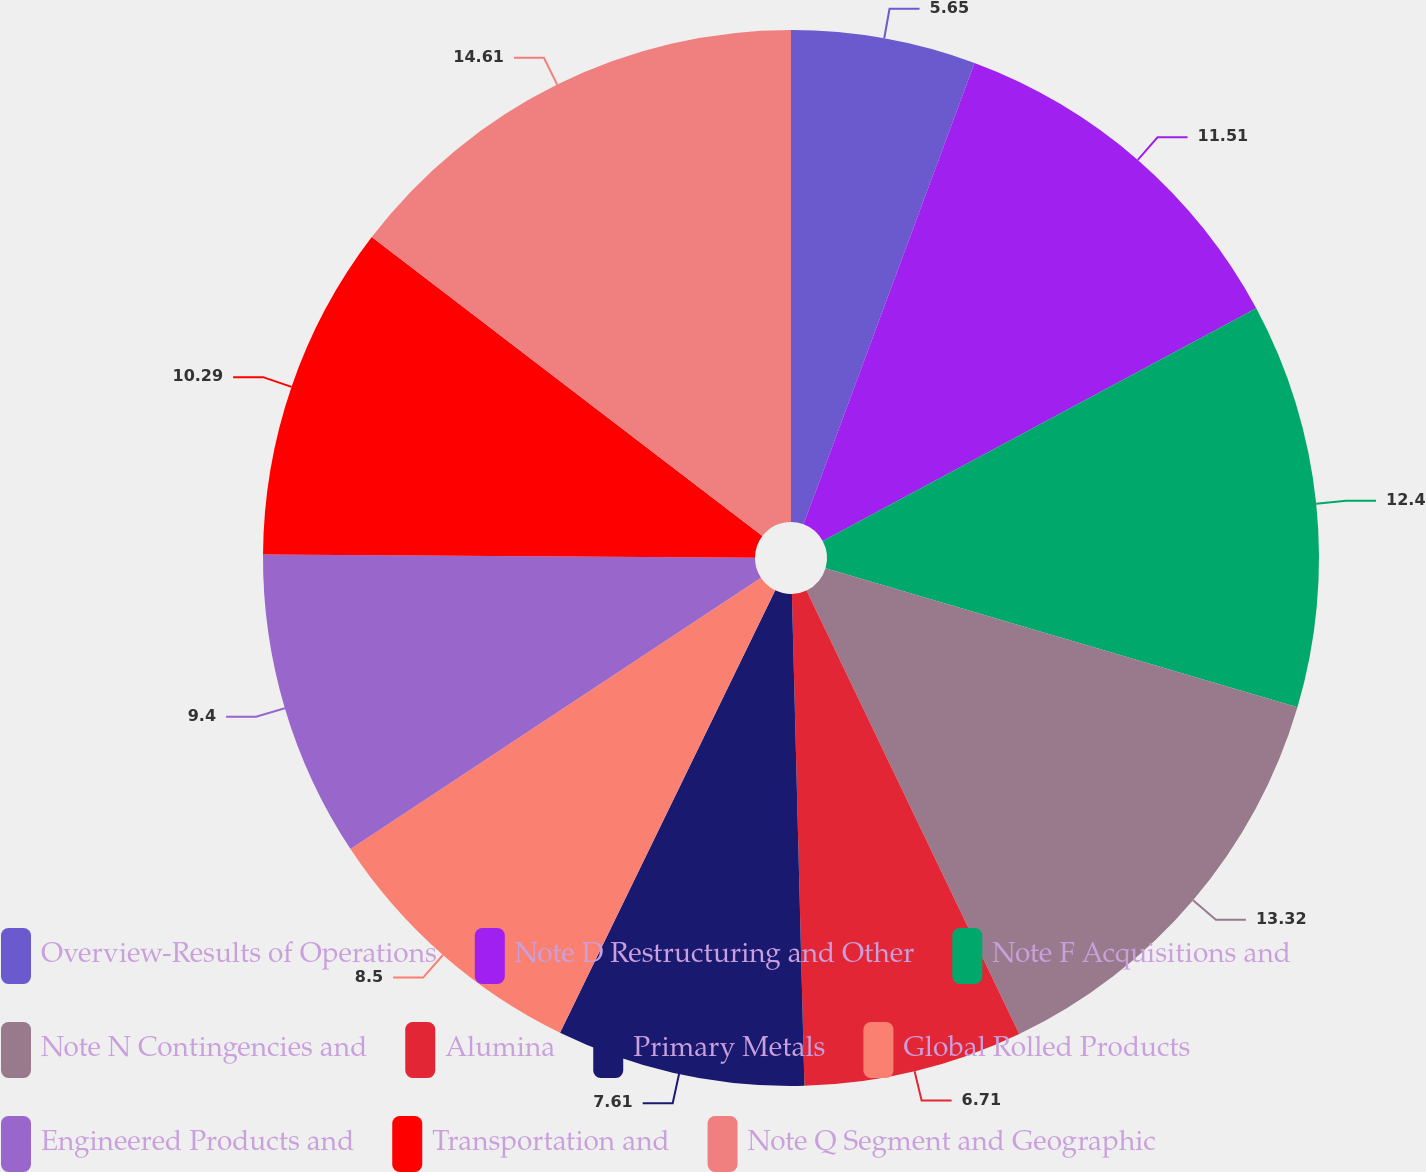Convert chart. <chart><loc_0><loc_0><loc_500><loc_500><pie_chart><fcel>Overview-Results of Operations<fcel>Note D Restructuring and Other<fcel>Note F Acquisitions and<fcel>Note N Contingencies and<fcel>Alumina<fcel>Primary Metals<fcel>Global Rolled Products<fcel>Engineered Products and<fcel>Transportation and<fcel>Note Q Segment and Geographic<nl><fcel>5.65%<fcel>11.51%<fcel>12.4%<fcel>13.32%<fcel>6.71%<fcel>7.61%<fcel>8.5%<fcel>9.4%<fcel>10.29%<fcel>14.6%<nl></chart> 